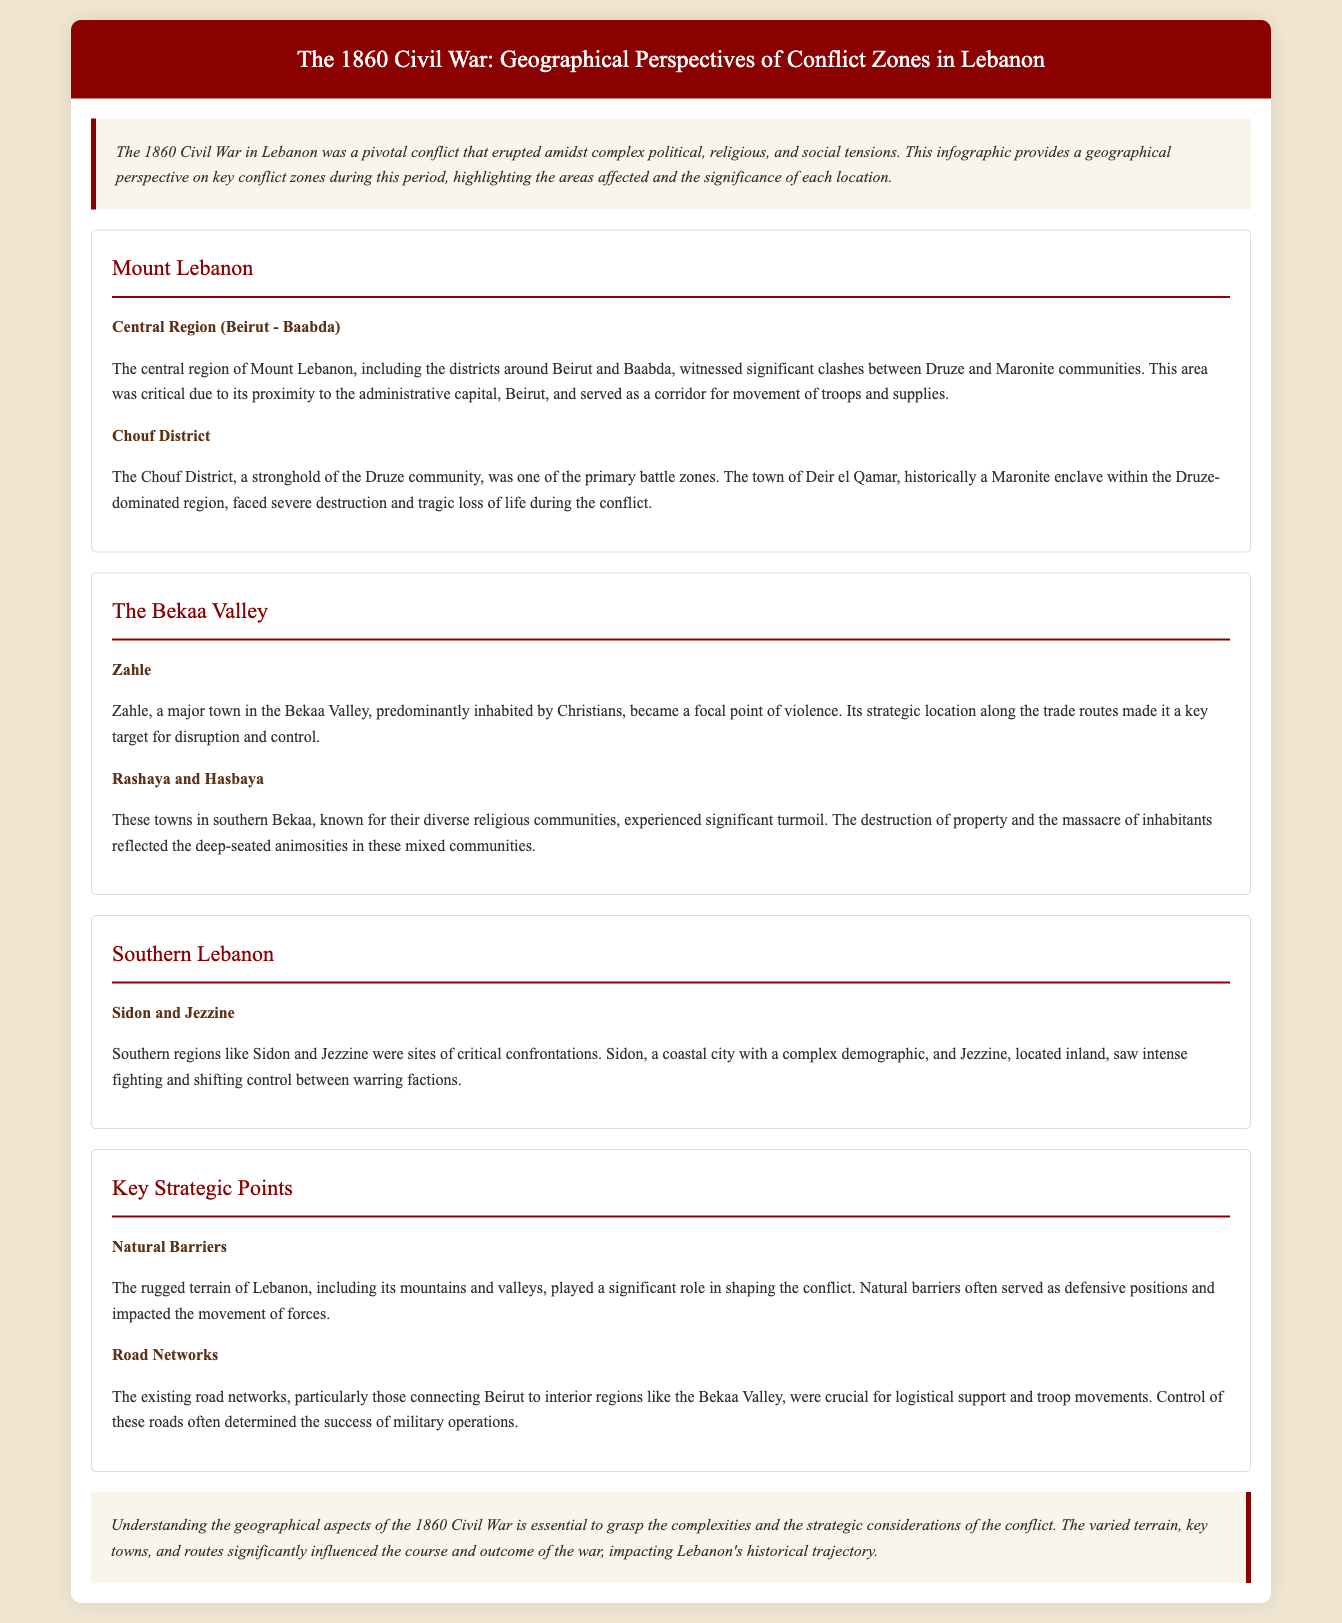What were the primary communities involved in the conflict in Mount Lebanon? The primary communities involved were the Druze and Maronite communities.
Answer: Druze and Maronite Which town in the Chouf District faced severe destruction? The town of Deir el Qamar faced severe destruction during the conflict.
Answer: Deir el Qamar What was the significance of Zahle during the Civil War? Zahle's strategic location along the trade routes made it a key target for disruption and control.
Answer: Strategic location What role did natural barriers play in the conflict? Natural barriers served as defensive positions and impacted the movement of forces.
Answer: Defensive positions Which region experienced significant turmoil in Rashaya and Hasbaya? Rashaya and Hasbaya experienced significant turmoil due to their diverse religious communities.
Answer: Diverse religious communities What impact did road networks have on military operations? Control of road networks determined the success of military operations.
Answer: Success of military operations What area witnessed critical confrontations between factions? Southern regions like Sidon and Jezzine witnessed critical confrontations.
Answer: Sidon and Jezzine What was the central region mentioned in the document? The central region mentioned is the area around Beirut and Baabda.
Answer: Beirut and Baabda 